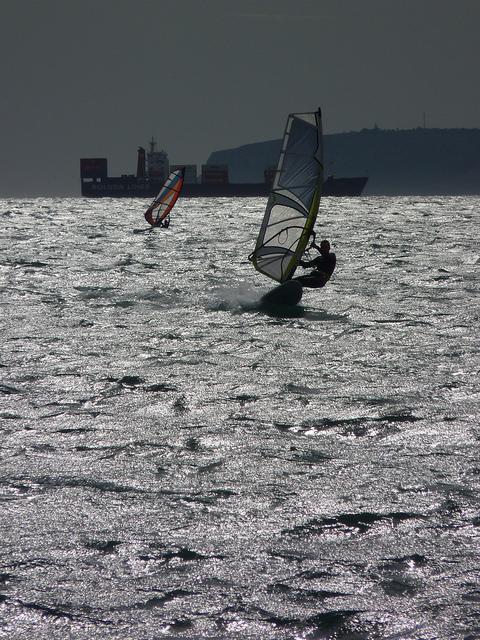How many boats are in the photo?
Give a very brief answer. 2. 